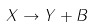<formula> <loc_0><loc_0><loc_500><loc_500>X \to Y + B</formula> 